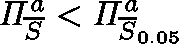Convert formula to latex. <formula><loc_0><loc_0><loc_500><loc_500>\Pi _ { \overline { S } } ^ { a } < \Pi _ { \overline { S } _ { 0 . 0 5 } } ^ { a }</formula> 